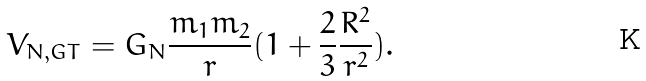Convert formula to latex. <formula><loc_0><loc_0><loc_500><loc_500>V _ { N , G T } = G _ { N } \frac { m _ { 1 } m _ { 2 } } { r } ( 1 + \frac { 2 } { 3 } \frac { R ^ { 2 } } { r ^ { 2 } } ) .</formula> 